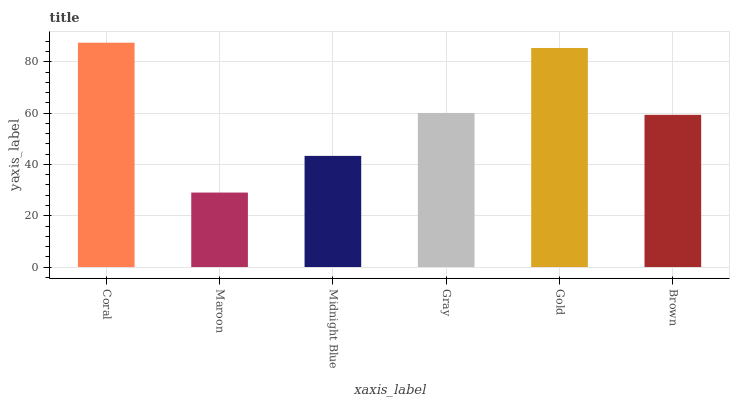Is Midnight Blue the minimum?
Answer yes or no. No. Is Midnight Blue the maximum?
Answer yes or no. No. Is Midnight Blue greater than Maroon?
Answer yes or no. Yes. Is Maroon less than Midnight Blue?
Answer yes or no. Yes. Is Maroon greater than Midnight Blue?
Answer yes or no. No. Is Midnight Blue less than Maroon?
Answer yes or no. No. Is Gray the high median?
Answer yes or no. Yes. Is Brown the low median?
Answer yes or no. Yes. Is Maroon the high median?
Answer yes or no. No. Is Gray the low median?
Answer yes or no. No. 